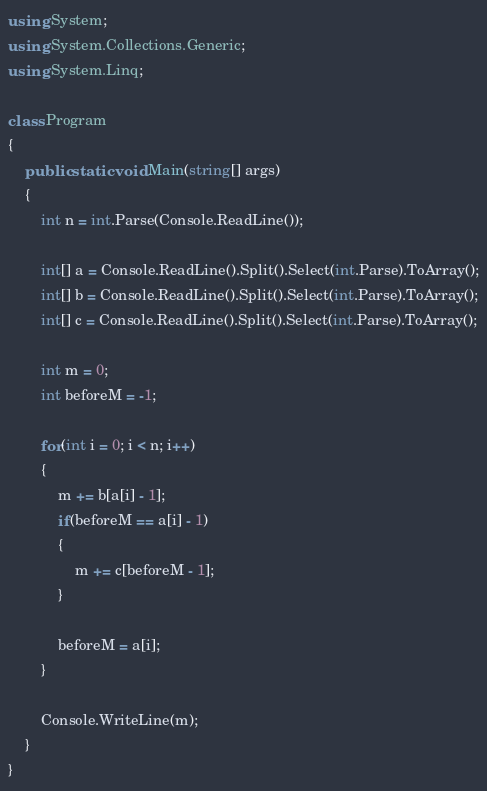<code> <loc_0><loc_0><loc_500><loc_500><_C#_>using System;
using System.Collections.Generic;
using System.Linq;

class Program
{
    public static void Main(string[] args)
    {
        int n = int.Parse(Console.ReadLine());

        int[] a = Console.ReadLine().Split().Select(int.Parse).ToArray();
        int[] b = Console.ReadLine().Split().Select(int.Parse).ToArray();
        int[] c = Console.ReadLine().Split().Select(int.Parse).ToArray();

        int m = 0;
        int beforeM = -1;

        for(int i = 0; i < n; i++)
        {
            m += b[a[i] - 1];
            if(beforeM == a[i] - 1)
            {
                m += c[beforeM - 1];
            }

            beforeM = a[i];
        }

        Console.WriteLine(m);
    }
}
</code> 